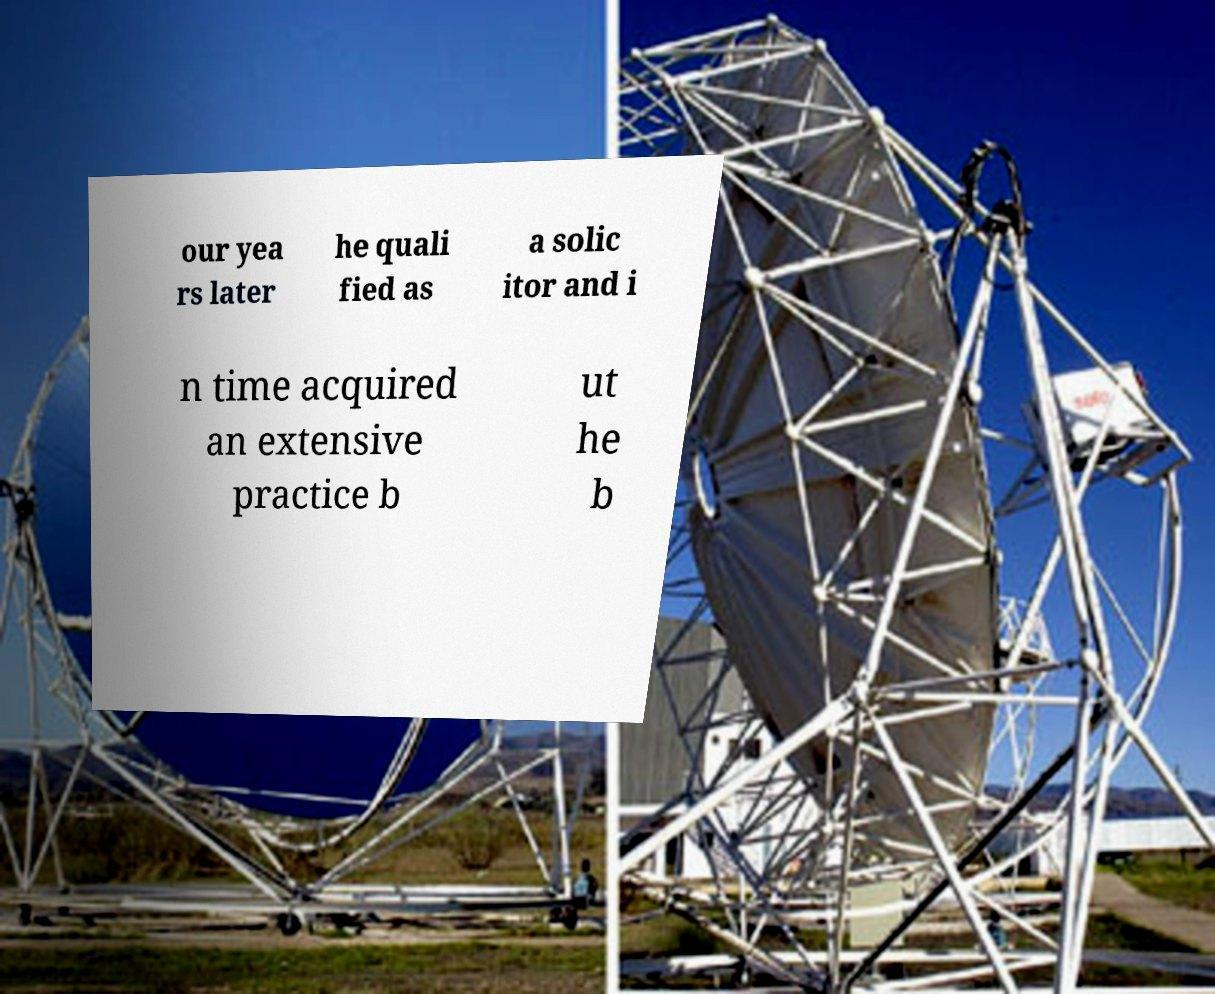Could you extract and type out the text from this image? our yea rs later he quali fied as a solic itor and i n time acquired an extensive practice b ut he b 